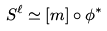Convert formula to latex. <formula><loc_0><loc_0><loc_500><loc_500>S ^ { \ell } \simeq [ m ] \circ \phi ^ { * }</formula> 